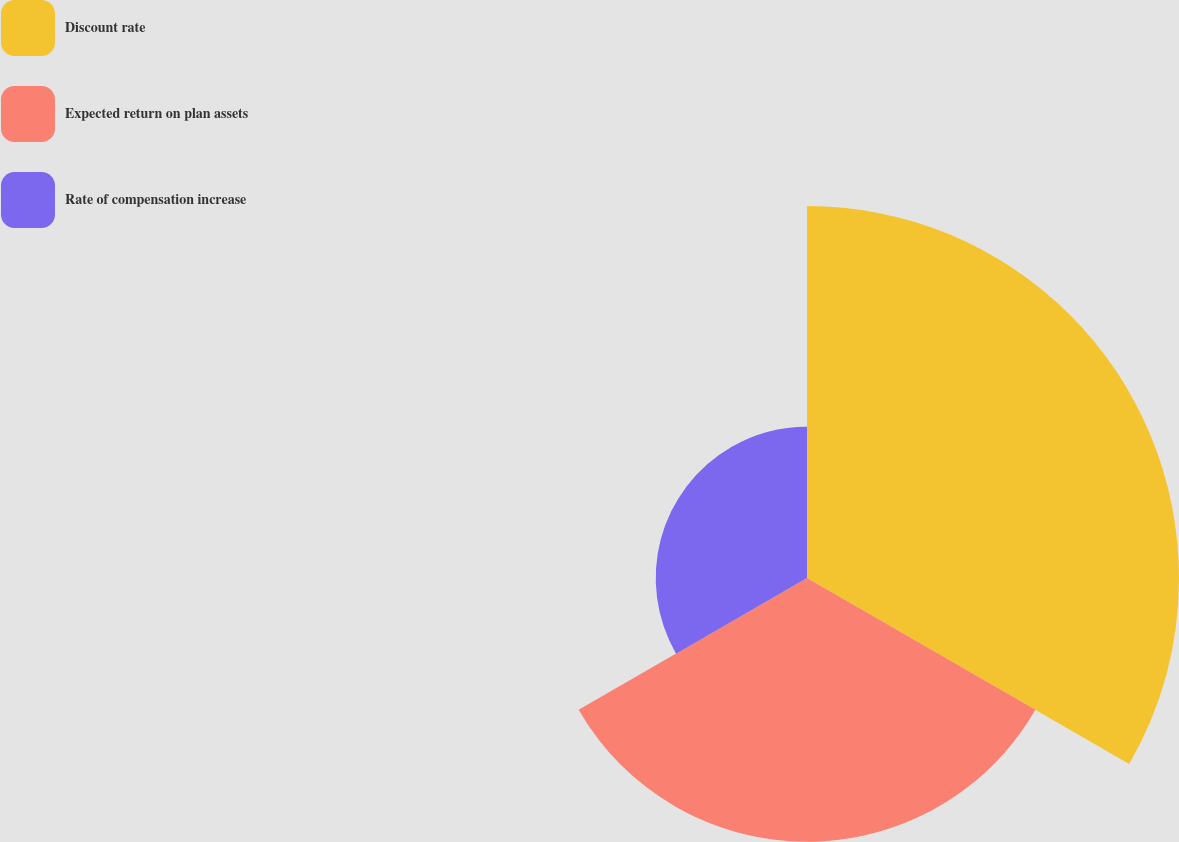Convert chart. <chart><loc_0><loc_0><loc_500><loc_500><pie_chart><fcel>Discount rate<fcel>Expected return on plan assets<fcel>Rate of compensation increase<nl><fcel>47.27%<fcel>33.51%<fcel>19.22%<nl></chart> 